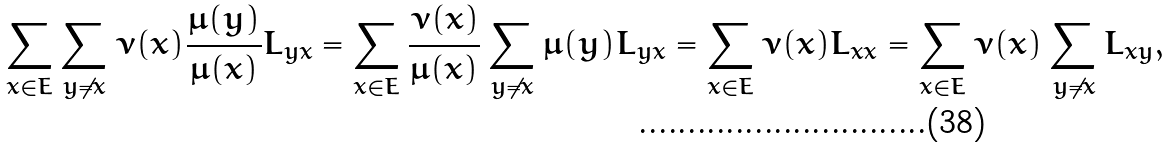Convert formula to latex. <formula><loc_0><loc_0><loc_500><loc_500>\sum _ { x \in E } \sum _ { y \neq x } \nu ( x ) \frac { \mu ( y ) } { \mu ( x ) } L _ { y x } = \sum _ { x \in E } \frac { \nu ( x ) } { \mu ( x ) } \sum _ { y \neq x } \mu ( y ) L _ { y x } = \sum _ { x \in E } \nu ( x ) L _ { x x } = \sum _ { x \in E } \nu ( x ) \sum _ { y \neq x } L _ { x y } ,</formula> 